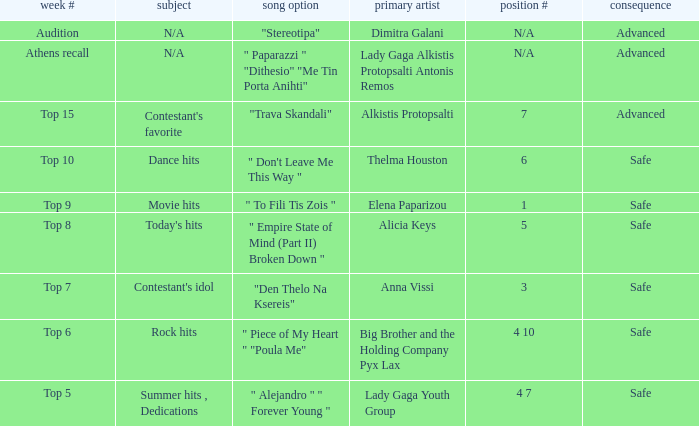Which artists hold sequence number 6? Thelma Houston. 